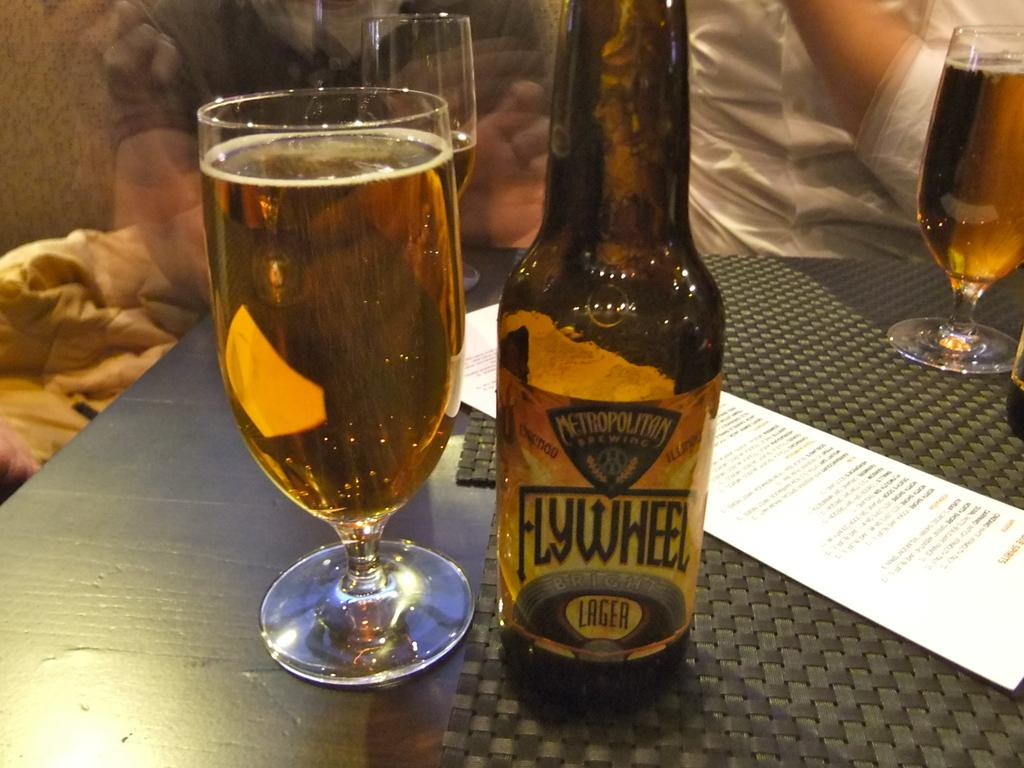<image>
Share a concise interpretation of the image provided. Cup of beer next to a bottle of beer that says Flywheel on it. 